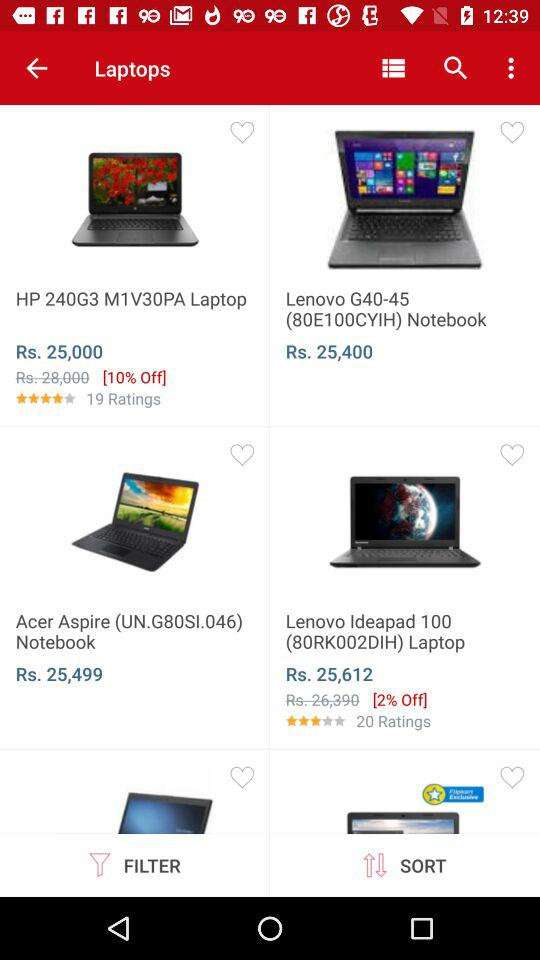What is the price of a "Lenovo G40-45" laptop? The price of a "Lenovo G40-45" laptop is Rs. 25,400. 